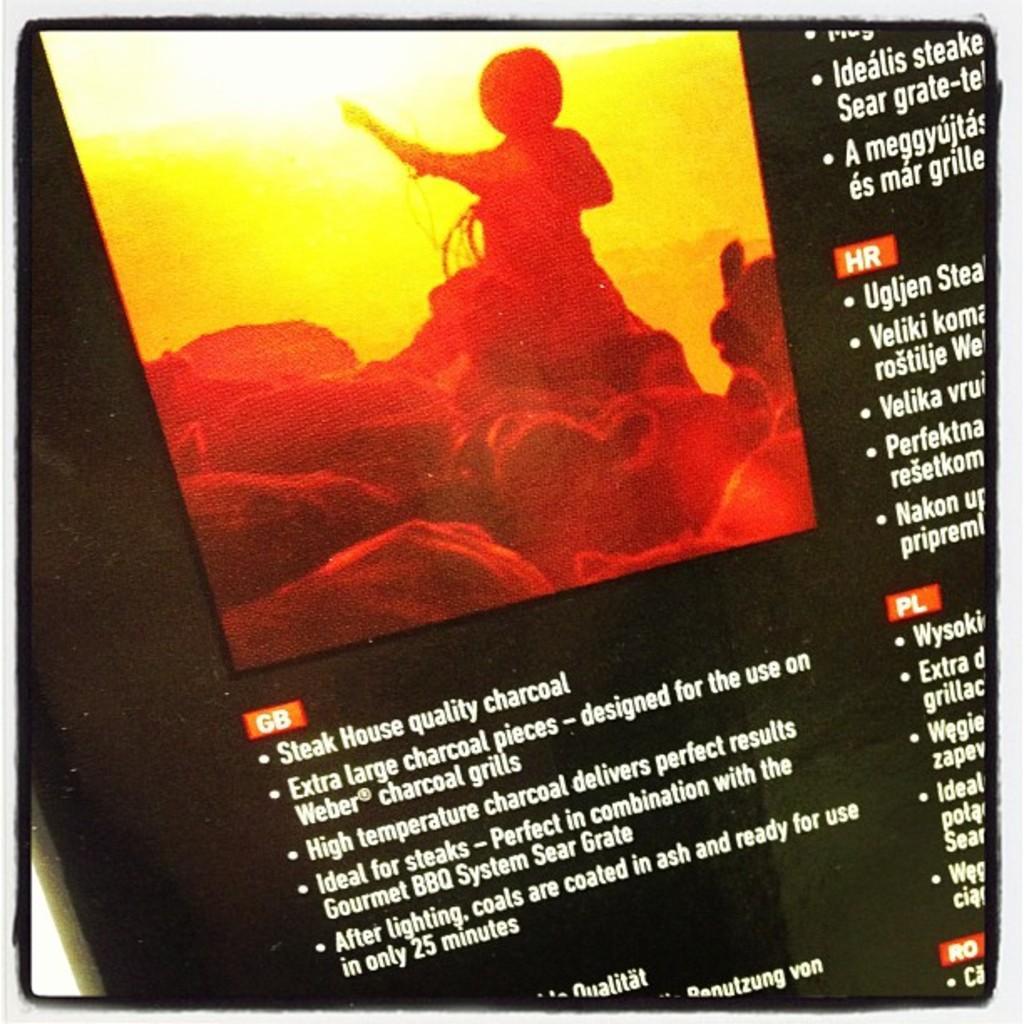Can you describe this image briefly? This is a edited image with a border, as we can see there is a painting at the top of this image and there is some text at the bottom of this image and on the right side of this image as well. 